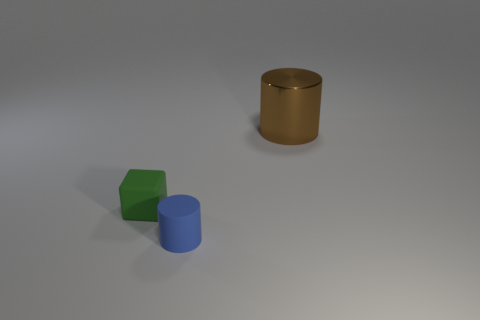Add 1 green objects. How many objects exist? 4 Subtract all cylinders. How many objects are left? 1 Subtract 0 purple balls. How many objects are left? 3 Subtract all brown objects. Subtract all small cyan metallic cylinders. How many objects are left? 2 Add 1 tiny blue matte cylinders. How many tiny blue matte cylinders are left? 2 Add 3 shiny cylinders. How many shiny cylinders exist? 4 